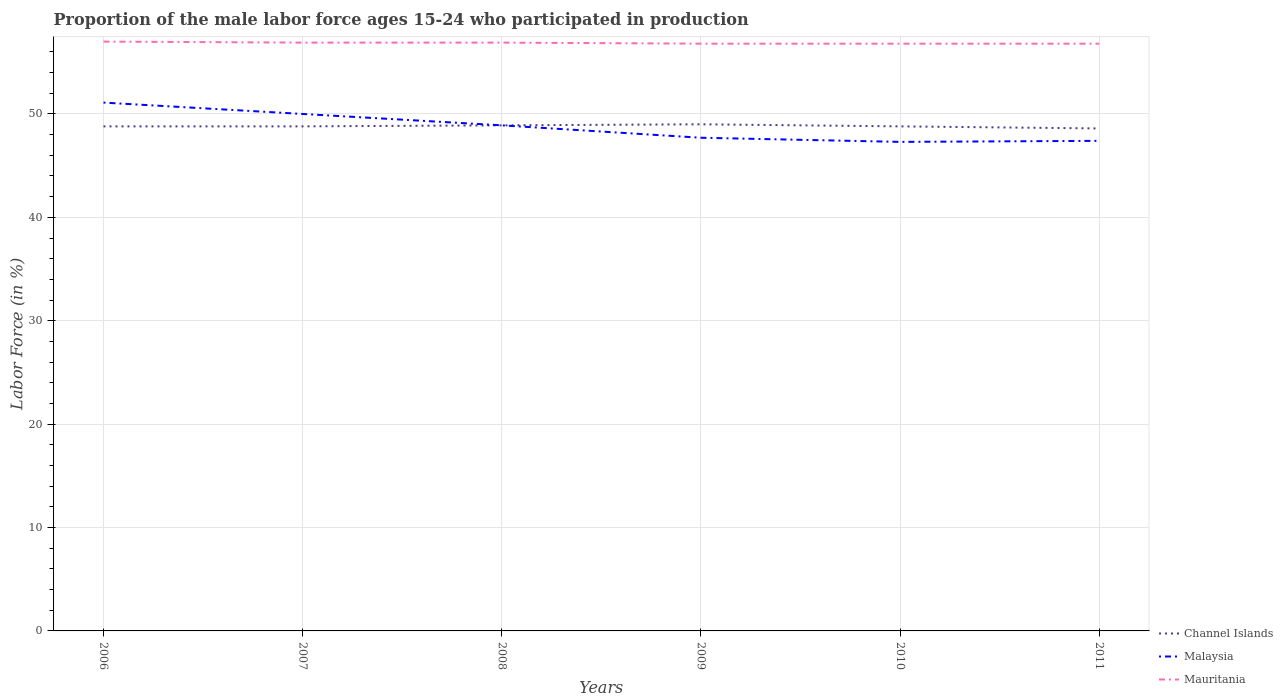Does the line corresponding to Malaysia intersect with the line corresponding to Mauritania?
Your response must be concise. No. Across all years, what is the maximum proportion of the male labor force who participated in production in Channel Islands?
Give a very brief answer. 48.6. In which year was the proportion of the male labor force who participated in production in Mauritania maximum?
Offer a terse response. 2009. What is the total proportion of the male labor force who participated in production in Mauritania in the graph?
Your answer should be compact. 0.2. What is the difference between the highest and the second highest proportion of the male labor force who participated in production in Channel Islands?
Ensure brevity in your answer.  0.4. Is the proportion of the male labor force who participated in production in Mauritania strictly greater than the proportion of the male labor force who participated in production in Channel Islands over the years?
Provide a succinct answer. No. How many years are there in the graph?
Provide a succinct answer. 6. What is the difference between two consecutive major ticks on the Y-axis?
Keep it short and to the point. 10. Are the values on the major ticks of Y-axis written in scientific E-notation?
Ensure brevity in your answer.  No. Does the graph contain any zero values?
Offer a terse response. No. How are the legend labels stacked?
Ensure brevity in your answer.  Vertical. What is the title of the graph?
Ensure brevity in your answer.  Proportion of the male labor force ages 15-24 who participated in production. What is the label or title of the X-axis?
Make the answer very short. Years. What is the Labor Force (in %) of Channel Islands in 2006?
Provide a succinct answer. 48.8. What is the Labor Force (in %) of Malaysia in 2006?
Offer a very short reply. 51.1. What is the Labor Force (in %) of Channel Islands in 2007?
Your response must be concise. 48.8. What is the Labor Force (in %) in Malaysia in 2007?
Keep it short and to the point. 50. What is the Labor Force (in %) in Mauritania in 2007?
Your answer should be very brief. 56.9. What is the Labor Force (in %) of Channel Islands in 2008?
Your answer should be compact. 48.9. What is the Labor Force (in %) in Malaysia in 2008?
Make the answer very short. 48.9. What is the Labor Force (in %) of Mauritania in 2008?
Make the answer very short. 56.9. What is the Labor Force (in %) of Channel Islands in 2009?
Make the answer very short. 49. What is the Labor Force (in %) of Malaysia in 2009?
Provide a succinct answer. 47.7. What is the Labor Force (in %) of Mauritania in 2009?
Keep it short and to the point. 56.8. What is the Labor Force (in %) of Channel Islands in 2010?
Offer a terse response. 48.8. What is the Labor Force (in %) of Malaysia in 2010?
Provide a succinct answer. 47.3. What is the Labor Force (in %) of Mauritania in 2010?
Provide a succinct answer. 56.8. What is the Labor Force (in %) in Channel Islands in 2011?
Provide a short and direct response. 48.6. What is the Labor Force (in %) of Malaysia in 2011?
Ensure brevity in your answer.  47.4. What is the Labor Force (in %) in Mauritania in 2011?
Provide a short and direct response. 56.8. Across all years, what is the maximum Labor Force (in %) of Channel Islands?
Offer a very short reply. 49. Across all years, what is the maximum Labor Force (in %) in Malaysia?
Your response must be concise. 51.1. Across all years, what is the minimum Labor Force (in %) in Channel Islands?
Offer a terse response. 48.6. Across all years, what is the minimum Labor Force (in %) in Malaysia?
Ensure brevity in your answer.  47.3. Across all years, what is the minimum Labor Force (in %) in Mauritania?
Your response must be concise. 56.8. What is the total Labor Force (in %) of Channel Islands in the graph?
Your answer should be very brief. 292.9. What is the total Labor Force (in %) of Malaysia in the graph?
Your answer should be very brief. 292.4. What is the total Labor Force (in %) in Mauritania in the graph?
Give a very brief answer. 341.2. What is the difference between the Labor Force (in %) in Channel Islands in 2006 and that in 2007?
Make the answer very short. 0. What is the difference between the Labor Force (in %) of Mauritania in 2006 and that in 2007?
Your answer should be compact. 0.1. What is the difference between the Labor Force (in %) in Channel Islands in 2006 and that in 2008?
Provide a succinct answer. -0.1. What is the difference between the Labor Force (in %) in Channel Islands in 2006 and that in 2009?
Ensure brevity in your answer.  -0.2. What is the difference between the Labor Force (in %) of Mauritania in 2006 and that in 2010?
Ensure brevity in your answer.  0.2. What is the difference between the Labor Force (in %) in Channel Islands in 2006 and that in 2011?
Your answer should be compact. 0.2. What is the difference between the Labor Force (in %) in Malaysia in 2007 and that in 2008?
Offer a very short reply. 1.1. What is the difference between the Labor Force (in %) in Malaysia in 2007 and that in 2009?
Your answer should be very brief. 2.3. What is the difference between the Labor Force (in %) in Mauritania in 2007 and that in 2009?
Offer a terse response. 0.1. What is the difference between the Labor Force (in %) in Channel Islands in 2007 and that in 2010?
Give a very brief answer. 0. What is the difference between the Labor Force (in %) in Mauritania in 2007 and that in 2010?
Provide a short and direct response. 0.1. What is the difference between the Labor Force (in %) in Channel Islands in 2007 and that in 2011?
Offer a very short reply. 0.2. What is the difference between the Labor Force (in %) in Malaysia in 2007 and that in 2011?
Make the answer very short. 2.6. What is the difference between the Labor Force (in %) of Malaysia in 2008 and that in 2009?
Your answer should be compact. 1.2. What is the difference between the Labor Force (in %) of Mauritania in 2008 and that in 2009?
Offer a terse response. 0.1. What is the difference between the Labor Force (in %) of Channel Islands in 2008 and that in 2010?
Keep it short and to the point. 0.1. What is the difference between the Labor Force (in %) of Malaysia in 2008 and that in 2010?
Ensure brevity in your answer.  1.6. What is the difference between the Labor Force (in %) in Channel Islands in 2008 and that in 2011?
Your answer should be compact. 0.3. What is the difference between the Labor Force (in %) of Malaysia in 2008 and that in 2011?
Your answer should be compact. 1.5. What is the difference between the Labor Force (in %) in Channel Islands in 2009 and that in 2010?
Make the answer very short. 0.2. What is the difference between the Labor Force (in %) in Malaysia in 2009 and that in 2010?
Make the answer very short. 0.4. What is the difference between the Labor Force (in %) of Channel Islands in 2009 and that in 2011?
Offer a terse response. 0.4. What is the difference between the Labor Force (in %) in Channel Islands in 2010 and that in 2011?
Your answer should be very brief. 0.2. What is the difference between the Labor Force (in %) in Malaysia in 2010 and that in 2011?
Your response must be concise. -0.1. What is the difference between the Labor Force (in %) in Mauritania in 2010 and that in 2011?
Make the answer very short. 0. What is the difference between the Labor Force (in %) in Channel Islands in 2006 and the Labor Force (in %) in Mauritania in 2007?
Keep it short and to the point. -8.1. What is the difference between the Labor Force (in %) of Malaysia in 2006 and the Labor Force (in %) of Mauritania in 2007?
Offer a very short reply. -5.8. What is the difference between the Labor Force (in %) of Channel Islands in 2006 and the Labor Force (in %) of Malaysia in 2008?
Offer a terse response. -0.1. What is the difference between the Labor Force (in %) of Channel Islands in 2006 and the Labor Force (in %) of Mauritania in 2008?
Make the answer very short. -8.1. What is the difference between the Labor Force (in %) in Malaysia in 2006 and the Labor Force (in %) in Mauritania in 2008?
Provide a short and direct response. -5.8. What is the difference between the Labor Force (in %) in Channel Islands in 2006 and the Labor Force (in %) in Mauritania in 2009?
Your answer should be very brief. -8. What is the difference between the Labor Force (in %) in Channel Islands in 2006 and the Labor Force (in %) in Malaysia in 2010?
Your answer should be very brief. 1.5. What is the difference between the Labor Force (in %) of Channel Islands in 2006 and the Labor Force (in %) of Malaysia in 2011?
Make the answer very short. 1.4. What is the difference between the Labor Force (in %) in Malaysia in 2006 and the Labor Force (in %) in Mauritania in 2011?
Offer a very short reply. -5.7. What is the difference between the Labor Force (in %) of Channel Islands in 2007 and the Labor Force (in %) of Malaysia in 2008?
Offer a terse response. -0.1. What is the difference between the Labor Force (in %) of Channel Islands in 2007 and the Labor Force (in %) of Malaysia in 2009?
Your response must be concise. 1.1. What is the difference between the Labor Force (in %) of Channel Islands in 2007 and the Labor Force (in %) of Mauritania in 2010?
Your answer should be compact. -8. What is the difference between the Labor Force (in %) of Malaysia in 2007 and the Labor Force (in %) of Mauritania in 2010?
Provide a succinct answer. -6.8. What is the difference between the Labor Force (in %) in Channel Islands in 2007 and the Labor Force (in %) in Mauritania in 2011?
Give a very brief answer. -8. What is the difference between the Labor Force (in %) in Channel Islands in 2008 and the Labor Force (in %) in Malaysia in 2009?
Make the answer very short. 1.2. What is the difference between the Labor Force (in %) of Channel Islands in 2008 and the Labor Force (in %) of Mauritania in 2009?
Your answer should be compact. -7.9. What is the difference between the Labor Force (in %) in Channel Islands in 2008 and the Labor Force (in %) in Mauritania in 2010?
Offer a terse response. -7.9. What is the difference between the Labor Force (in %) of Malaysia in 2008 and the Labor Force (in %) of Mauritania in 2010?
Offer a terse response. -7.9. What is the difference between the Labor Force (in %) in Channel Islands in 2008 and the Labor Force (in %) in Malaysia in 2011?
Offer a terse response. 1.5. What is the difference between the Labor Force (in %) in Malaysia in 2008 and the Labor Force (in %) in Mauritania in 2011?
Ensure brevity in your answer.  -7.9. What is the difference between the Labor Force (in %) in Channel Islands in 2009 and the Labor Force (in %) in Malaysia in 2010?
Keep it short and to the point. 1.7. What is the difference between the Labor Force (in %) of Malaysia in 2009 and the Labor Force (in %) of Mauritania in 2010?
Make the answer very short. -9.1. What is the difference between the Labor Force (in %) in Channel Islands in 2009 and the Labor Force (in %) in Mauritania in 2011?
Provide a succinct answer. -7.8. What is the difference between the Labor Force (in %) of Malaysia in 2009 and the Labor Force (in %) of Mauritania in 2011?
Your response must be concise. -9.1. What is the difference between the Labor Force (in %) of Channel Islands in 2010 and the Labor Force (in %) of Mauritania in 2011?
Keep it short and to the point. -8. What is the difference between the Labor Force (in %) of Malaysia in 2010 and the Labor Force (in %) of Mauritania in 2011?
Your response must be concise. -9.5. What is the average Labor Force (in %) in Channel Islands per year?
Ensure brevity in your answer.  48.82. What is the average Labor Force (in %) of Malaysia per year?
Offer a very short reply. 48.73. What is the average Labor Force (in %) of Mauritania per year?
Your answer should be very brief. 56.87. In the year 2006, what is the difference between the Labor Force (in %) of Channel Islands and Labor Force (in %) of Malaysia?
Provide a succinct answer. -2.3. In the year 2006, what is the difference between the Labor Force (in %) of Channel Islands and Labor Force (in %) of Mauritania?
Keep it short and to the point. -8.2. In the year 2007, what is the difference between the Labor Force (in %) in Malaysia and Labor Force (in %) in Mauritania?
Offer a terse response. -6.9. In the year 2009, what is the difference between the Labor Force (in %) in Channel Islands and Labor Force (in %) in Mauritania?
Your answer should be compact. -7.8. In the year 2009, what is the difference between the Labor Force (in %) in Malaysia and Labor Force (in %) in Mauritania?
Your answer should be very brief. -9.1. In the year 2011, what is the difference between the Labor Force (in %) of Channel Islands and Labor Force (in %) of Mauritania?
Your answer should be very brief. -8.2. What is the ratio of the Labor Force (in %) in Malaysia in 2006 to that in 2007?
Offer a very short reply. 1.02. What is the ratio of the Labor Force (in %) in Mauritania in 2006 to that in 2007?
Offer a very short reply. 1. What is the ratio of the Labor Force (in %) in Malaysia in 2006 to that in 2008?
Offer a terse response. 1.04. What is the ratio of the Labor Force (in %) in Malaysia in 2006 to that in 2009?
Provide a succinct answer. 1.07. What is the ratio of the Labor Force (in %) of Mauritania in 2006 to that in 2009?
Your answer should be compact. 1. What is the ratio of the Labor Force (in %) of Channel Islands in 2006 to that in 2010?
Make the answer very short. 1. What is the ratio of the Labor Force (in %) of Malaysia in 2006 to that in 2010?
Your response must be concise. 1.08. What is the ratio of the Labor Force (in %) of Mauritania in 2006 to that in 2010?
Ensure brevity in your answer.  1. What is the ratio of the Labor Force (in %) of Channel Islands in 2006 to that in 2011?
Keep it short and to the point. 1. What is the ratio of the Labor Force (in %) of Malaysia in 2006 to that in 2011?
Your answer should be very brief. 1.08. What is the ratio of the Labor Force (in %) of Malaysia in 2007 to that in 2008?
Give a very brief answer. 1.02. What is the ratio of the Labor Force (in %) in Channel Islands in 2007 to that in 2009?
Provide a succinct answer. 1. What is the ratio of the Labor Force (in %) of Malaysia in 2007 to that in 2009?
Keep it short and to the point. 1.05. What is the ratio of the Labor Force (in %) in Channel Islands in 2007 to that in 2010?
Provide a short and direct response. 1. What is the ratio of the Labor Force (in %) in Malaysia in 2007 to that in 2010?
Your response must be concise. 1.06. What is the ratio of the Labor Force (in %) in Mauritania in 2007 to that in 2010?
Your answer should be compact. 1. What is the ratio of the Labor Force (in %) in Malaysia in 2007 to that in 2011?
Provide a short and direct response. 1.05. What is the ratio of the Labor Force (in %) of Mauritania in 2007 to that in 2011?
Provide a succinct answer. 1. What is the ratio of the Labor Force (in %) in Channel Islands in 2008 to that in 2009?
Provide a short and direct response. 1. What is the ratio of the Labor Force (in %) in Malaysia in 2008 to that in 2009?
Your answer should be very brief. 1.03. What is the ratio of the Labor Force (in %) of Channel Islands in 2008 to that in 2010?
Make the answer very short. 1. What is the ratio of the Labor Force (in %) of Malaysia in 2008 to that in 2010?
Make the answer very short. 1.03. What is the ratio of the Labor Force (in %) of Malaysia in 2008 to that in 2011?
Give a very brief answer. 1.03. What is the ratio of the Labor Force (in %) of Channel Islands in 2009 to that in 2010?
Provide a succinct answer. 1. What is the ratio of the Labor Force (in %) of Malaysia in 2009 to that in 2010?
Give a very brief answer. 1.01. What is the ratio of the Labor Force (in %) of Channel Islands in 2009 to that in 2011?
Make the answer very short. 1.01. What is the ratio of the Labor Force (in %) in Malaysia in 2009 to that in 2011?
Offer a very short reply. 1.01. What is the ratio of the Labor Force (in %) in Mauritania in 2009 to that in 2011?
Provide a succinct answer. 1. What is the ratio of the Labor Force (in %) of Channel Islands in 2010 to that in 2011?
Your answer should be compact. 1. What is the ratio of the Labor Force (in %) in Mauritania in 2010 to that in 2011?
Make the answer very short. 1. What is the difference between the highest and the second highest Labor Force (in %) in Malaysia?
Provide a succinct answer. 1.1. What is the difference between the highest and the lowest Labor Force (in %) in Malaysia?
Provide a succinct answer. 3.8. 